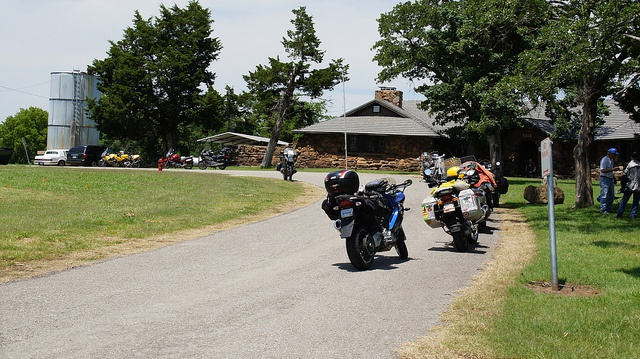Describe the objects in this image and their specific colors. I can see motorcycle in lightgray, black, gray, and darkgray tones, motorcycle in lightgray, black, gray, and darkgray tones, people in lightgray, black, navy, blue, and gray tones, car in lightgray, black, gray, and blue tones, and people in lightgray, black, gray, navy, and darkgray tones in this image. 